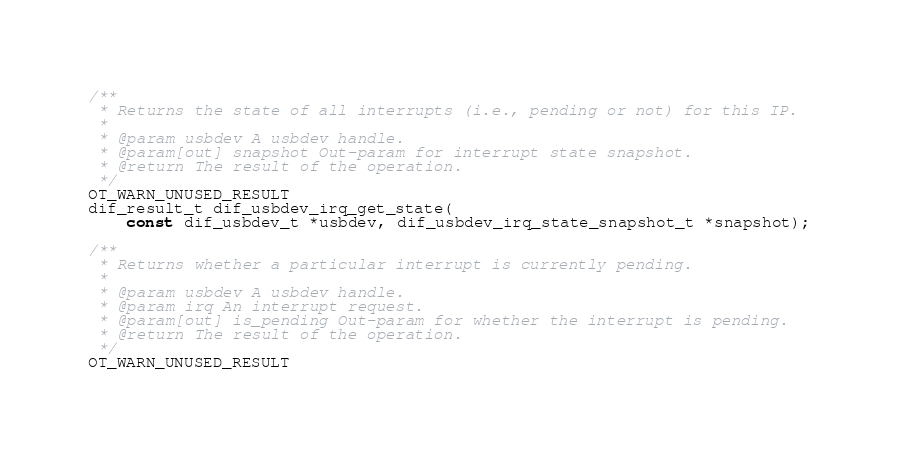<code> <loc_0><loc_0><loc_500><loc_500><_C_>
/**
 * Returns the state of all interrupts (i.e., pending or not) for this IP.
 *
 * @param usbdev A usbdev handle.
 * @param[out] snapshot Out-param for interrupt state snapshot.
 * @return The result of the operation.
 */
OT_WARN_UNUSED_RESULT
dif_result_t dif_usbdev_irq_get_state(
    const dif_usbdev_t *usbdev, dif_usbdev_irq_state_snapshot_t *snapshot);

/**
 * Returns whether a particular interrupt is currently pending.
 *
 * @param usbdev A usbdev handle.
 * @param irq An interrupt request.
 * @param[out] is_pending Out-param for whether the interrupt is pending.
 * @return The result of the operation.
 */
OT_WARN_UNUSED_RESULT</code> 